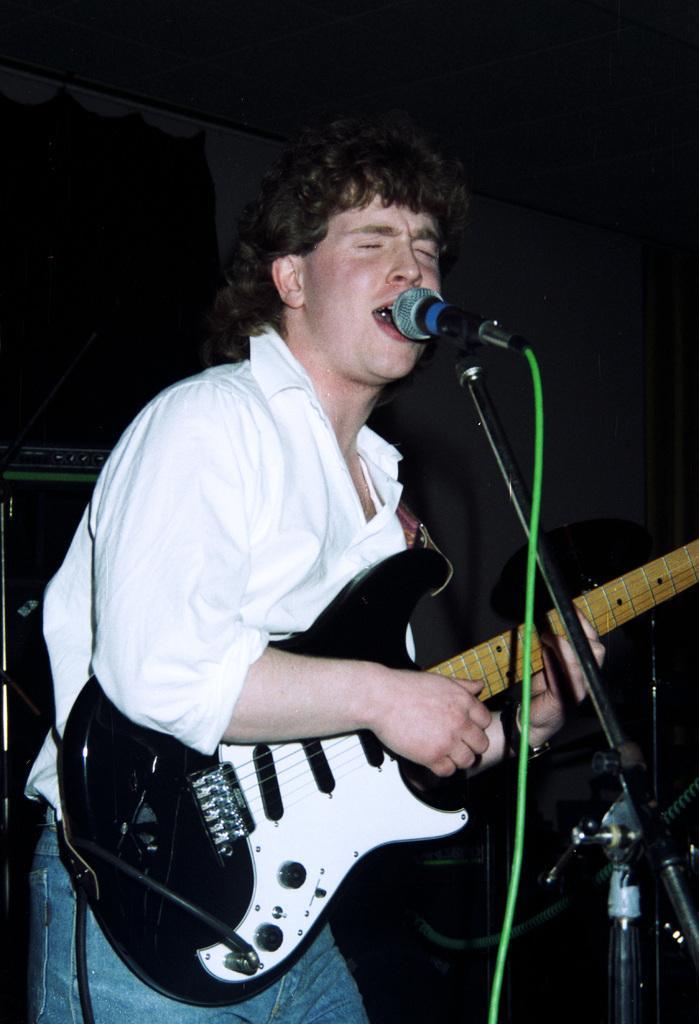In one or two sentences, can you explain what this image depicts? In this image we can see a man standing holding a guitar. We can also see a mic with a stand in front of him. On the backside we can see a device placed aside. We can also see some curtains and a wall. 